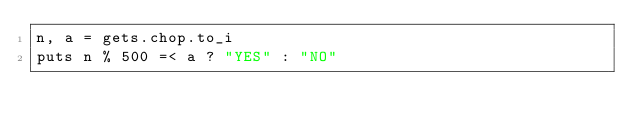<code> <loc_0><loc_0><loc_500><loc_500><_Ruby_>n, a = gets.chop.to_i
puts n % 500 =< a ? "YES" : "NO"</code> 